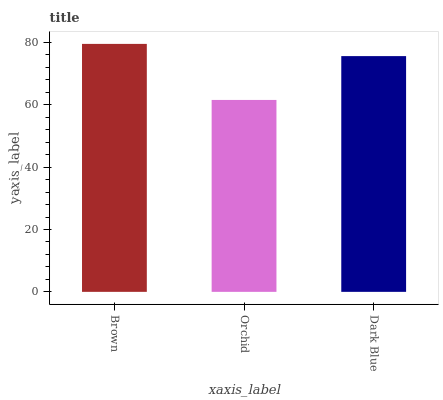Is Brown the maximum?
Answer yes or no. Yes. Is Dark Blue the minimum?
Answer yes or no. No. Is Dark Blue the maximum?
Answer yes or no. No. Is Dark Blue greater than Orchid?
Answer yes or no. Yes. Is Orchid less than Dark Blue?
Answer yes or no. Yes. Is Orchid greater than Dark Blue?
Answer yes or no. No. Is Dark Blue less than Orchid?
Answer yes or no. No. Is Dark Blue the high median?
Answer yes or no. Yes. Is Dark Blue the low median?
Answer yes or no. Yes. Is Orchid the high median?
Answer yes or no. No. Is Brown the low median?
Answer yes or no. No. 